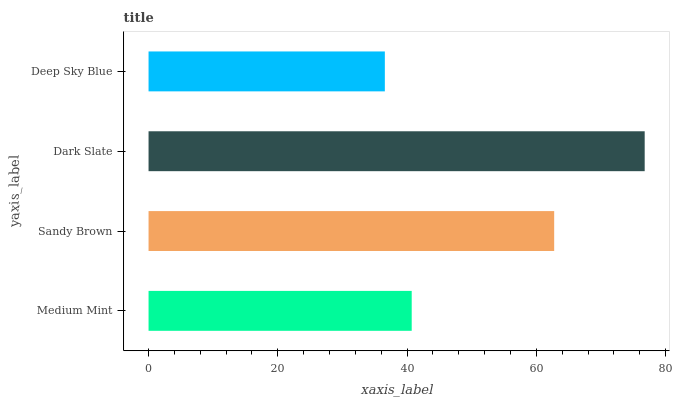Is Deep Sky Blue the minimum?
Answer yes or no. Yes. Is Dark Slate the maximum?
Answer yes or no. Yes. Is Sandy Brown the minimum?
Answer yes or no. No. Is Sandy Brown the maximum?
Answer yes or no. No. Is Sandy Brown greater than Medium Mint?
Answer yes or no. Yes. Is Medium Mint less than Sandy Brown?
Answer yes or no. Yes. Is Medium Mint greater than Sandy Brown?
Answer yes or no. No. Is Sandy Brown less than Medium Mint?
Answer yes or no. No. Is Sandy Brown the high median?
Answer yes or no. Yes. Is Medium Mint the low median?
Answer yes or no. Yes. Is Medium Mint the high median?
Answer yes or no. No. Is Dark Slate the low median?
Answer yes or no. No. 